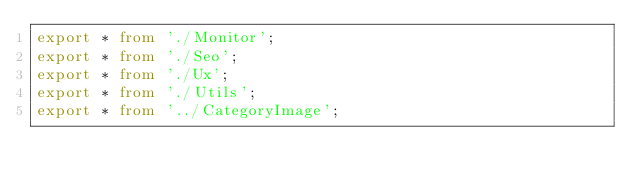<code> <loc_0><loc_0><loc_500><loc_500><_TypeScript_>export * from './Monitor';
export * from './Seo';
export * from './Ux';
export * from './Utils';
export * from '../CategoryImage';
</code> 